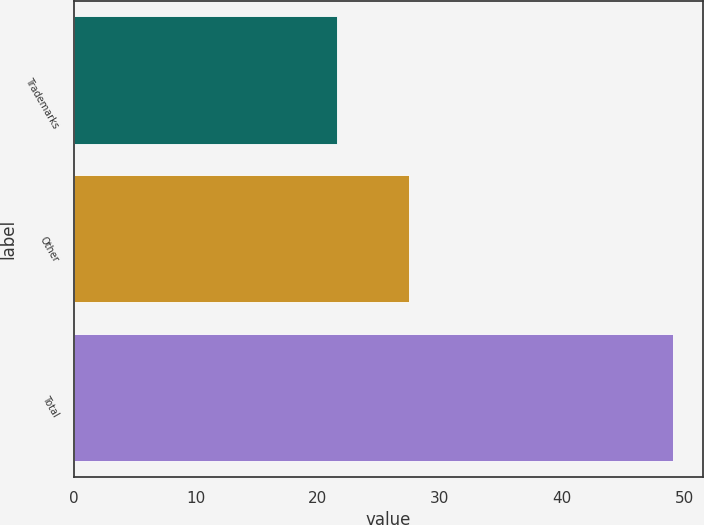<chart> <loc_0><loc_0><loc_500><loc_500><bar_chart><fcel>Trademarks<fcel>Other<fcel>Total<nl><fcel>21.6<fcel>27.5<fcel>49.1<nl></chart> 